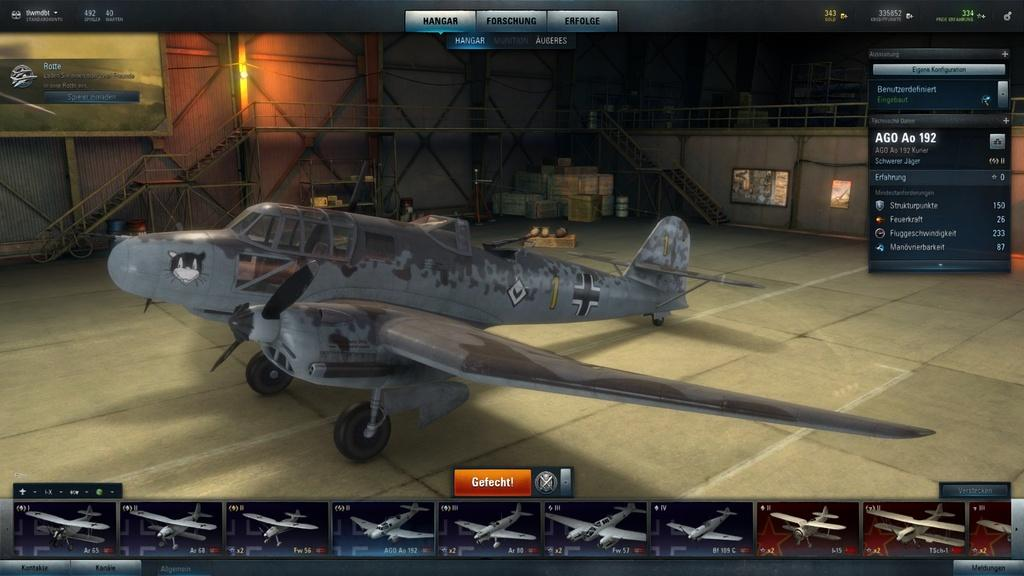<image>
Relay a brief, clear account of the picture shown. a computer program for model airplanes has the word GEFECHT! on it 